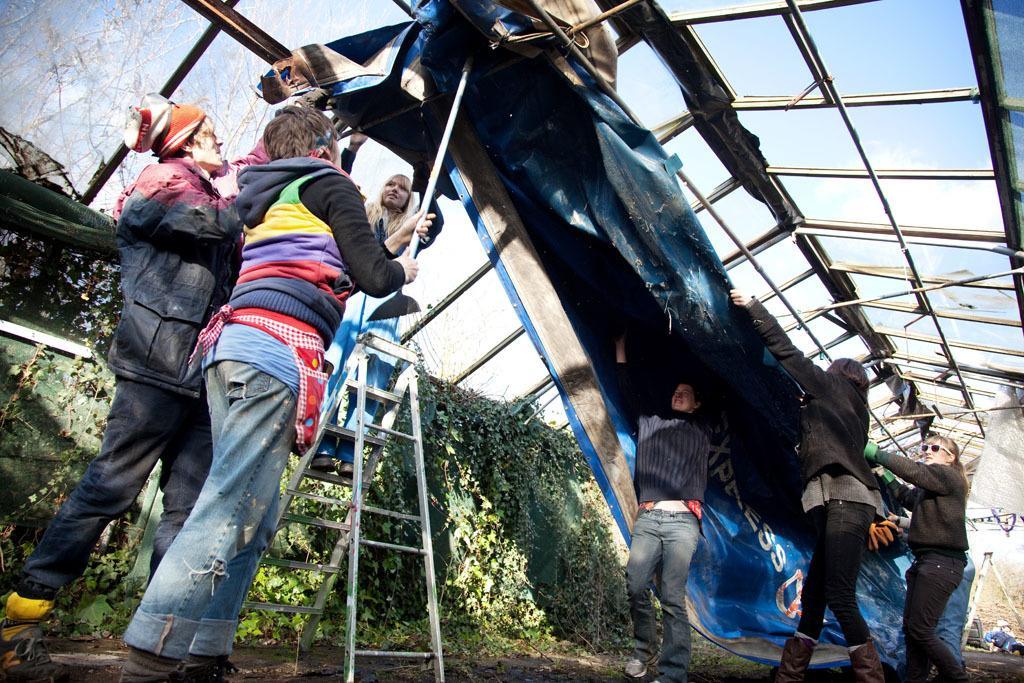Please provide a concise description of this image. In this picture we can observe some people. There are men and women in this picture. We can observe a white color ladder and blue color tent. There are some plants. In the background there is a sky. 